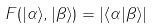Convert formula to latex. <formula><loc_0><loc_0><loc_500><loc_500>F ( | \alpha \rangle , | \beta \rangle ) = | \langle \alpha | \beta \rangle |</formula> 